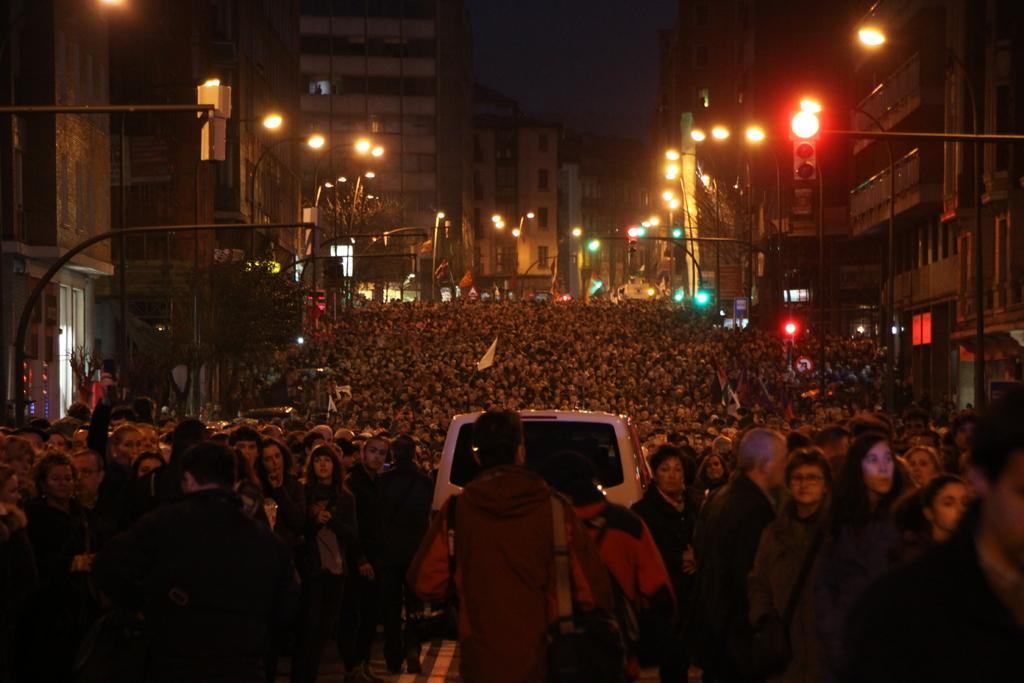Could you give a brief overview of what you see in this image? In this picture in the front there is a man standing and on the right side there are buildings, lights and there are persons. In the background there are group of persons, there is a vehicle and there are buildings and there are light poles. 